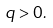Convert formula to latex. <formula><loc_0><loc_0><loc_500><loc_500>q > 0 .</formula> 